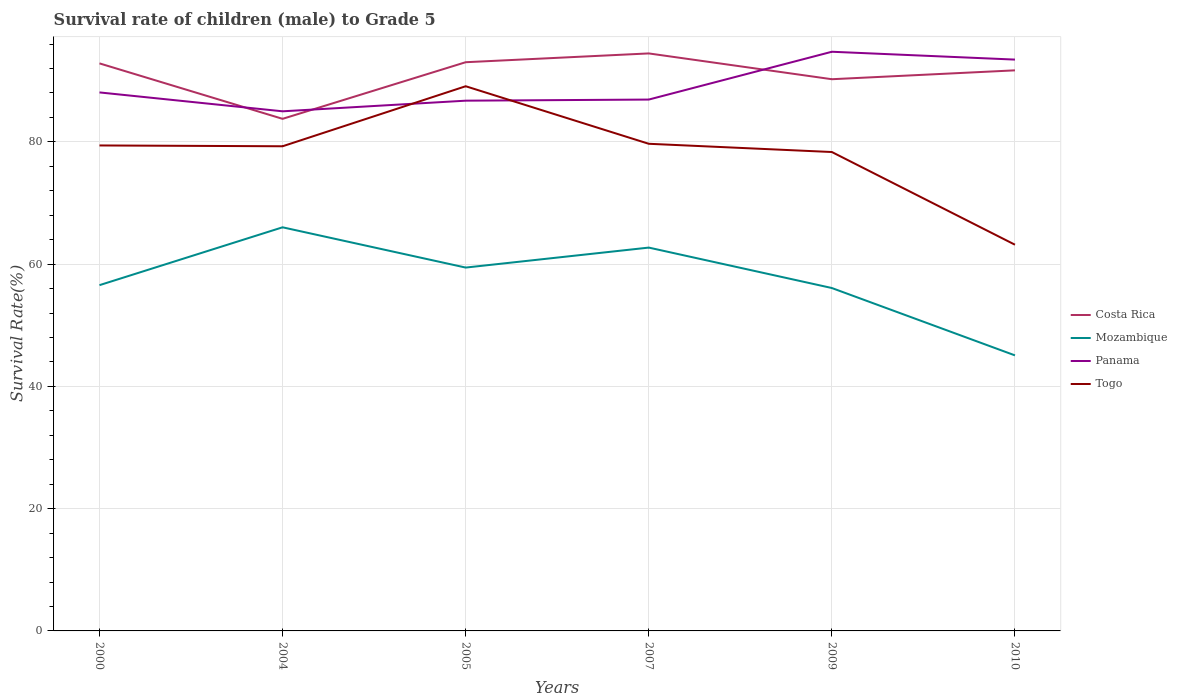Is the number of lines equal to the number of legend labels?
Make the answer very short. Yes. Across all years, what is the maximum survival rate of male children to grade 5 in Togo?
Your answer should be very brief. 63.17. In which year was the survival rate of male children to grade 5 in Costa Rica maximum?
Give a very brief answer. 2004. What is the total survival rate of male children to grade 5 in Costa Rica in the graph?
Provide a short and direct response. -10.7. What is the difference between the highest and the second highest survival rate of male children to grade 5 in Mozambique?
Your response must be concise. 20.95. What is the difference between the highest and the lowest survival rate of male children to grade 5 in Costa Rica?
Provide a succinct answer. 4. Is the survival rate of male children to grade 5 in Togo strictly greater than the survival rate of male children to grade 5 in Panama over the years?
Your answer should be compact. No. How many years are there in the graph?
Your response must be concise. 6. What is the difference between two consecutive major ticks on the Y-axis?
Provide a short and direct response. 20. Are the values on the major ticks of Y-axis written in scientific E-notation?
Provide a short and direct response. No. Does the graph contain any zero values?
Offer a terse response. No. Where does the legend appear in the graph?
Give a very brief answer. Center right. How are the legend labels stacked?
Your answer should be compact. Vertical. What is the title of the graph?
Ensure brevity in your answer.  Survival rate of children (male) to Grade 5. Does "Costa Rica" appear as one of the legend labels in the graph?
Your response must be concise. Yes. What is the label or title of the Y-axis?
Keep it short and to the point. Survival Rate(%). What is the Survival Rate(%) in Costa Rica in 2000?
Make the answer very short. 92.83. What is the Survival Rate(%) of Mozambique in 2000?
Offer a very short reply. 56.56. What is the Survival Rate(%) in Panama in 2000?
Your response must be concise. 88.08. What is the Survival Rate(%) of Togo in 2000?
Provide a short and direct response. 79.41. What is the Survival Rate(%) of Costa Rica in 2004?
Provide a succinct answer. 83.76. What is the Survival Rate(%) in Mozambique in 2004?
Give a very brief answer. 66.02. What is the Survival Rate(%) of Panama in 2004?
Keep it short and to the point. 84.99. What is the Survival Rate(%) in Togo in 2004?
Give a very brief answer. 79.28. What is the Survival Rate(%) in Costa Rica in 2005?
Offer a terse response. 93.02. What is the Survival Rate(%) in Mozambique in 2005?
Offer a terse response. 59.43. What is the Survival Rate(%) of Panama in 2005?
Your answer should be compact. 86.73. What is the Survival Rate(%) of Togo in 2005?
Your answer should be very brief. 89.09. What is the Survival Rate(%) of Costa Rica in 2007?
Provide a short and direct response. 94.46. What is the Survival Rate(%) of Mozambique in 2007?
Give a very brief answer. 62.7. What is the Survival Rate(%) of Panama in 2007?
Keep it short and to the point. 86.91. What is the Survival Rate(%) in Togo in 2007?
Offer a very short reply. 79.68. What is the Survival Rate(%) of Costa Rica in 2009?
Make the answer very short. 90.24. What is the Survival Rate(%) of Mozambique in 2009?
Your answer should be very brief. 56.09. What is the Survival Rate(%) in Panama in 2009?
Give a very brief answer. 94.73. What is the Survival Rate(%) in Togo in 2009?
Your answer should be very brief. 78.33. What is the Survival Rate(%) in Costa Rica in 2010?
Your answer should be compact. 91.69. What is the Survival Rate(%) of Mozambique in 2010?
Provide a succinct answer. 45.07. What is the Survival Rate(%) in Panama in 2010?
Provide a short and direct response. 93.45. What is the Survival Rate(%) in Togo in 2010?
Keep it short and to the point. 63.17. Across all years, what is the maximum Survival Rate(%) of Costa Rica?
Offer a terse response. 94.46. Across all years, what is the maximum Survival Rate(%) of Mozambique?
Your response must be concise. 66.02. Across all years, what is the maximum Survival Rate(%) of Panama?
Offer a terse response. 94.73. Across all years, what is the maximum Survival Rate(%) of Togo?
Ensure brevity in your answer.  89.09. Across all years, what is the minimum Survival Rate(%) of Costa Rica?
Offer a very short reply. 83.76. Across all years, what is the minimum Survival Rate(%) of Mozambique?
Keep it short and to the point. 45.07. Across all years, what is the minimum Survival Rate(%) of Panama?
Offer a terse response. 84.99. Across all years, what is the minimum Survival Rate(%) of Togo?
Your answer should be compact. 63.17. What is the total Survival Rate(%) in Costa Rica in the graph?
Give a very brief answer. 546.01. What is the total Survival Rate(%) in Mozambique in the graph?
Give a very brief answer. 345.87. What is the total Survival Rate(%) in Panama in the graph?
Offer a terse response. 534.91. What is the total Survival Rate(%) in Togo in the graph?
Provide a short and direct response. 468.96. What is the difference between the Survival Rate(%) of Costa Rica in 2000 and that in 2004?
Your answer should be compact. 9.07. What is the difference between the Survival Rate(%) of Mozambique in 2000 and that in 2004?
Offer a very short reply. -9.46. What is the difference between the Survival Rate(%) of Panama in 2000 and that in 2004?
Give a very brief answer. 3.09. What is the difference between the Survival Rate(%) in Togo in 2000 and that in 2004?
Keep it short and to the point. 0.13. What is the difference between the Survival Rate(%) of Costa Rica in 2000 and that in 2005?
Offer a terse response. -0.19. What is the difference between the Survival Rate(%) in Mozambique in 2000 and that in 2005?
Your response must be concise. -2.88. What is the difference between the Survival Rate(%) of Panama in 2000 and that in 2005?
Offer a very short reply. 1.35. What is the difference between the Survival Rate(%) of Togo in 2000 and that in 2005?
Your answer should be compact. -9.69. What is the difference between the Survival Rate(%) in Costa Rica in 2000 and that in 2007?
Your answer should be compact. -1.63. What is the difference between the Survival Rate(%) in Mozambique in 2000 and that in 2007?
Give a very brief answer. -6.14. What is the difference between the Survival Rate(%) in Panama in 2000 and that in 2007?
Make the answer very short. 1.17. What is the difference between the Survival Rate(%) of Togo in 2000 and that in 2007?
Your response must be concise. -0.27. What is the difference between the Survival Rate(%) in Costa Rica in 2000 and that in 2009?
Keep it short and to the point. 2.59. What is the difference between the Survival Rate(%) in Mozambique in 2000 and that in 2009?
Keep it short and to the point. 0.47. What is the difference between the Survival Rate(%) of Panama in 2000 and that in 2009?
Offer a very short reply. -6.65. What is the difference between the Survival Rate(%) in Togo in 2000 and that in 2009?
Your response must be concise. 1.07. What is the difference between the Survival Rate(%) in Costa Rica in 2000 and that in 2010?
Give a very brief answer. 1.14. What is the difference between the Survival Rate(%) of Mozambique in 2000 and that in 2010?
Provide a short and direct response. 11.49. What is the difference between the Survival Rate(%) of Panama in 2000 and that in 2010?
Your answer should be very brief. -5.37. What is the difference between the Survival Rate(%) of Togo in 2000 and that in 2010?
Offer a terse response. 16.24. What is the difference between the Survival Rate(%) in Costa Rica in 2004 and that in 2005?
Provide a short and direct response. -9.26. What is the difference between the Survival Rate(%) of Mozambique in 2004 and that in 2005?
Make the answer very short. 6.59. What is the difference between the Survival Rate(%) in Panama in 2004 and that in 2005?
Your answer should be compact. -1.74. What is the difference between the Survival Rate(%) in Togo in 2004 and that in 2005?
Offer a terse response. -9.82. What is the difference between the Survival Rate(%) in Costa Rica in 2004 and that in 2007?
Make the answer very short. -10.7. What is the difference between the Survival Rate(%) in Mozambique in 2004 and that in 2007?
Make the answer very short. 3.32. What is the difference between the Survival Rate(%) in Panama in 2004 and that in 2007?
Provide a succinct answer. -1.92. What is the difference between the Survival Rate(%) in Togo in 2004 and that in 2007?
Provide a succinct answer. -0.41. What is the difference between the Survival Rate(%) in Costa Rica in 2004 and that in 2009?
Your answer should be compact. -6.48. What is the difference between the Survival Rate(%) in Mozambique in 2004 and that in 2009?
Your response must be concise. 9.93. What is the difference between the Survival Rate(%) of Panama in 2004 and that in 2009?
Keep it short and to the point. -9.74. What is the difference between the Survival Rate(%) of Togo in 2004 and that in 2009?
Your answer should be compact. 0.94. What is the difference between the Survival Rate(%) in Costa Rica in 2004 and that in 2010?
Your answer should be very brief. -7.93. What is the difference between the Survival Rate(%) in Mozambique in 2004 and that in 2010?
Give a very brief answer. 20.95. What is the difference between the Survival Rate(%) of Panama in 2004 and that in 2010?
Keep it short and to the point. -8.46. What is the difference between the Survival Rate(%) in Togo in 2004 and that in 2010?
Keep it short and to the point. 16.1. What is the difference between the Survival Rate(%) in Costa Rica in 2005 and that in 2007?
Ensure brevity in your answer.  -1.44. What is the difference between the Survival Rate(%) in Mozambique in 2005 and that in 2007?
Your response must be concise. -3.27. What is the difference between the Survival Rate(%) of Panama in 2005 and that in 2007?
Provide a short and direct response. -0.18. What is the difference between the Survival Rate(%) of Togo in 2005 and that in 2007?
Keep it short and to the point. 9.41. What is the difference between the Survival Rate(%) of Costa Rica in 2005 and that in 2009?
Ensure brevity in your answer.  2.78. What is the difference between the Survival Rate(%) of Mozambique in 2005 and that in 2009?
Offer a terse response. 3.35. What is the difference between the Survival Rate(%) in Panama in 2005 and that in 2009?
Your answer should be very brief. -8. What is the difference between the Survival Rate(%) of Togo in 2005 and that in 2009?
Provide a short and direct response. 10.76. What is the difference between the Survival Rate(%) of Costa Rica in 2005 and that in 2010?
Keep it short and to the point. 1.33. What is the difference between the Survival Rate(%) of Mozambique in 2005 and that in 2010?
Give a very brief answer. 14.36. What is the difference between the Survival Rate(%) in Panama in 2005 and that in 2010?
Keep it short and to the point. -6.72. What is the difference between the Survival Rate(%) in Togo in 2005 and that in 2010?
Your answer should be compact. 25.92. What is the difference between the Survival Rate(%) in Costa Rica in 2007 and that in 2009?
Make the answer very short. 4.22. What is the difference between the Survival Rate(%) in Mozambique in 2007 and that in 2009?
Offer a very short reply. 6.61. What is the difference between the Survival Rate(%) of Panama in 2007 and that in 2009?
Ensure brevity in your answer.  -7.82. What is the difference between the Survival Rate(%) of Togo in 2007 and that in 2009?
Make the answer very short. 1.35. What is the difference between the Survival Rate(%) of Costa Rica in 2007 and that in 2010?
Keep it short and to the point. 2.77. What is the difference between the Survival Rate(%) in Mozambique in 2007 and that in 2010?
Ensure brevity in your answer.  17.63. What is the difference between the Survival Rate(%) of Panama in 2007 and that in 2010?
Keep it short and to the point. -6.54. What is the difference between the Survival Rate(%) in Togo in 2007 and that in 2010?
Make the answer very short. 16.51. What is the difference between the Survival Rate(%) in Costa Rica in 2009 and that in 2010?
Your answer should be compact. -1.45. What is the difference between the Survival Rate(%) in Mozambique in 2009 and that in 2010?
Ensure brevity in your answer.  11.02. What is the difference between the Survival Rate(%) of Panama in 2009 and that in 2010?
Your response must be concise. 1.28. What is the difference between the Survival Rate(%) of Togo in 2009 and that in 2010?
Your response must be concise. 15.16. What is the difference between the Survival Rate(%) in Costa Rica in 2000 and the Survival Rate(%) in Mozambique in 2004?
Your answer should be very brief. 26.81. What is the difference between the Survival Rate(%) of Costa Rica in 2000 and the Survival Rate(%) of Panama in 2004?
Keep it short and to the point. 7.84. What is the difference between the Survival Rate(%) in Costa Rica in 2000 and the Survival Rate(%) in Togo in 2004?
Provide a short and direct response. 13.56. What is the difference between the Survival Rate(%) of Mozambique in 2000 and the Survival Rate(%) of Panama in 2004?
Offer a very short reply. -28.44. What is the difference between the Survival Rate(%) in Mozambique in 2000 and the Survival Rate(%) in Togo in 2004?
Offer a terse response. -22.72. What is the difference between the Survival Rate(%) in Panama in 2000 and the Survival Rate(%) in Togo in 2004?
Make the answer very short. 8.81. What is the difference between the Survival Rate(%) in Costa Rica in 2000 and the Survival Rate(%) in Mozambique in 2005?
Offer a terse response. 33.4. What is the difference between the Survival Rate(%) of Costa Rica in 2000 and the Survival Rate(%) of Panama in 2005?
Offer a very short reply. 6.1. What is the difference between the Survival Rate(%) of Costa Rica in 2000 and the Survival Rate(%) of Togo in 2005?
Give a very brief answer. 3.74. What is the difference between the Survival Rate(%) of Mozambique in 2000 and the Survival Rate(%) of Panama in 2005?
Offer a very short reply. -30.17. What is the difference between the Survival Rate(%) in Mozambique in 2000 and the Survival Rate(%) in Togo in 2005?
Ensure brevity in your answer.  -32.54. What is the difference between the Survival Rate(%) in Panama in 2000 and the Survival Rate(%) in Togo in 2005?
Your answer should be very brief. -1.01. What is the difference between the Survival Rate(%) of Costa Rica in 2000 and the Survival Rate(%) of Mozambique in 2007?
Your answer should be very brief. 30.13. What is the difference between the Survival Rate(%) in Costa Rica in 2000 and the Survival Rate(%) in Panama in 2007?
Ensure brevity in your answer.  5.92. What is the difference between the Survival Rate(%) of Costa Rica in 2000 and the Survival Rate(%) of Togo in 2007?
Give a very brief answer. 13.15. What is the difference between the Survival Rate(%) of Mozambique in 2000 and the Survival Rate(%) of Panama in 2007?
Your response must be concise. -30.36. What is the difference between the Survival Rate(%) of Mozambique in 2000 and the Survival Rate(%) of Togo in 2007?
Offer a terse response. -23.12. What is the difference between the Survival Rate(%) in Panama in 2000 and the Survival Rate(%) in Togo in 2007?
Offer a very short reply. 8.4. What is the difference between the Survival Rate(%) of Costa Rica in 2000 and the Survival Rate(%) of Mozambique in 2009?
Offer a very short reply. 36.75. What is the difference between the Survival Rate(%) of Costa Rica in 2000 and the Survival Rate(%) of Panama in 2009?
Provide a succinct answer. -1.9. What is the difference between the Survival Rate(%) of Costa Rica in 2000 and the Survival Rate(%) of Togo in 2009?
Keep it short and to the point. 14.5. What is the difference between the Survival Rate(%) of Mozambique in 2000 and the Survival Rate(%) of Panama in 2009?
Offer a very short reply. -38.18. What is the difference between the Survival Rate(%) in Mozambique in 2000 and the Survival Rate(%) in Togo in 2009?
Provide a short and direct response. -21.78. What is the difference between the Survival Rate(%) of Panama in 2000 and the Survival Rate(%) of Togo in 2009?
Offer a very short reply. 9.75. What is the difference between the Survival Rate(%) of Costa Rica in 2000 and the Survival Rate(%) of Mozambique in 2010?
Ensure brevity in your answer.  47.76. What is the difference between the Survival Rate(%) in Costa Rica in 2000 and the Survival Rate(%) in Panama in 2010?
Give a very brief answer. -0.62. What is the difference between the Survival Rate(%) in Costa Rica in 2000 and the Survival Rate(%) in Togo in 2010?
Give a very brief answer. 29.66. What is the difference between the Survival Rate(%) of Mozambique in 2000 and the Survival Rate(%) of Panama in 2010?
Your response must be concise. -36.9. What is the difference between the Survival Rate(%) of Mozambique in 2000 and the Survival Rate(%) of Togo in 2010?
Your response must be concise. -6.62. What is the difference between the Survival Rate(%) of Panama in 2000 and the Survival Rate(%) of Togo in 2010?
Your answer should be very brief. 24.91. What is the difference between the Survival Rate(%) of Costa Rica in 2004 and the Survival Rate(%) of Mozambique in 2005?
Give a very brief answer. 24.33. What is the difference between the Survival Rate(%) of Costa Rica in 2004 and the Survival Rate(%) of Panama in 2005?
Keep it short and to the point. -2.97. What is the difference between the Survival Rate(%) in Costa Rica in 2004 and the Survival Rate(%) in Togo in 2005?
Your answer should be very brief. -5.33. What is the difference between the Survival Rate(%) of Mozambique in 2004 and the Survival Rate(%) of Panama in 2005?
Give a very brief answer. -20.71. What is the difference between the Survival Rate(%) of Mozambique in 2004 and the Survival Rate(%) of Togo in 2005?
Ensure brevity in your answer.  -23.07. What is the difference between the Survival Rate(%) in Panama in 2004 and the Survival Rate(%) in Togo in 2005?
Make the answer very short. -4.1. What is the difference between the Survival Rate(%) of Costa Rica in 2004 and the Survival Rate(%) of Mozambique in 2007?
Make the answer very short. 21.06. What is the difference between the Survival Rate(%) in Costa Rica in 2004 and the Survival Rate(%) in Panama in 2007?
Offer a very short reply. -3.15. What is the difference between the Survival Rate(%) of Costa Rica in 2004 and the Survival Rate(%) of Togo in 2007?
Ensure brevity in your answer.  4.08. What is the difference between the Survival Rate(%) in Mozambique in 2004 and the Survival Rate(%) in Panama in 2007?
Make the answer very short. -20.89. What is the difference between the Survival Rate(%) in Mozambique in 2004 and the Survival Rate(%) in Togo in 2007?
Make the answer very short. -13.66. What is the difference between the Survival Rate(%) in Panama in 2004 and the Survival Rate(%) in Togo in 2007?
Your response must be concise. 5.31. What is the difference between the Survival Rate(%) of Costa Rica in 2004 and the Survival Rate(%) of Mozambique in 2009?
Ensure brevity in your answer.  27.67. What is the difference between the Survival Rate(%) in Costa Rica in 2004 and the Survival Rate(%) in Panama in 2009?
Offer a terse response. -10.97. What is the difference between the Survival Rate(%) in Costa Rica in 2004 and the Survival Rate(%) in Togo in 2009?
Offer a very short reply. 5.43. What is the difference between the Survival Rate(%) in Mozambique in 2004 and the Survival Rate(%) in Panama in 2009?
Ensure brevity in your answer.  -28.71. What is the difference between the Survival Rate(%) of Mozambique in 2004 and the Survival Rate(%) of Togo in 2009?
Provide a short and direct response. -12.31. What is the difference between the Survival Rate(%) of Panama in 2004 and the Survival Rate(%) of Togo in 2009?
Offer a very short reply. 6.66. What is the difference between the Survival Rate(%) in Costa Rica in 2004 and the Survival Rate(%) in Mozambique in 2010?
Make the answer very short. 38.69. What is the difference between the Survival Rate(%) of Costa Rica in 2004 and the Survival Rate(%) of Panama in 2010?
Your answer should be compact. -9.69. What is the difference between the Survival Rate(%) of Costa Rica in 2004 and the Survival Rate(%) of Togo in 2010?
Provide a short and direct response. 20.59. What is the difference between the Survival Rate(%) of Mozambique in 2004 and the Survival Rate(%) of Panama in 2010?
Your answer should be very brief. -27.43. What is the difference between the Survival Rate(%) of Mozambique in 2004 and the Survival Rate(%) of Togo in 2010?
Make the answer very short. 2.85. What is the difference between the Survival Rate(%) in Panama in 2004 and the Survival Rate(%) in Togo in 2010?
Give a very brief answer. 21.82. What is the difference between the Survival Rate(%) in Costa Rica in 2005 and the Survival Rate(%) in Mozambique in 2007?
Give a very brief answer. 30.32. What is the difference between the Survival Rate(%) of Costa Rica in 2005 and the Survival Rate(%) of Panama in 2007?
Your answer should be very brief. 6.11. What is the difference between the Survival Rate(%) of Costa Rica in 2005 and the Survival Rate(%) of Togo in 2007?
Make the answer very short. 13.34. What is the difference between the Survival Rate(%) of Mozambique in 2005 and the Survival Rate(%) of Panama in 2007?
Provide a short and direct response. -27.48. What is the difference between the Survival Rate(%) of Mozambique in 2005 and the Survival Rate(%) of Togo in 2007?
Your answer should be compact. -20.25. What is the difference between the Survival Rate(%) in Panama in 2005 and the Survival Rate(%) in Togo in 2007?
Ensure brevity in your answer.  7.05. What is the difference between the Survival Rate(%) in Costa Rica in 2005 and the Survival Rate(%) in Mozambique in 2009?
Ensure brevity in your answer.  36.93. What is the difference between the Survival Rate(%) of Costa Rica in 2005 and the Survival Rate(%) of Panama in 2009?
Provide a succinct answer. -1.71. What is the difference between the Survival Rate(%) in Costa Rica in 2005 and the Survival Rate(%) in Togo in 2009?
Make the answer very short. 14.69. What is the difference between the Survival Rate(%) in Mozambique in 2005 and the Survival Rate(%) in Panama in 2009?
Offer a very short reply. -35.3. What is the difference between the Survival Rate(%) of Mozambique in 2005 and the Survival Rate(%) of Togo in 2009?
Your answer should be compact. -18.9. What is the difference between the Survival Rate(%) in Panama in 2005 and the Survival Rate(%) in Togo in 2009?
Provide a succinct answer. 8.4. What is the difference between the Survival Rate(%) of Costa Rica in 2005 and the Survival Rate(%) of Mozambique in 2010?
Ensure brevity in your answer.  47.95. What is the difference between the Survival Rate(%) in Costa Rica in 2005 and the Survival Rate(%) in Panama in 2010?
Offer a very short reply. -0.43. What is the difference between the Survival Rate(%) of Costa Rica in 2005 and the Survival Rate(%) of Togo in 2010?
Give a very brief answer. 29.85. What is the difference between the Survival Rate(%) of Mozambique in 2005 and the Survival Rate(%) of Panama in 2010?
Keep it short and to the point. -34.02. What is the difference between the Survival Rate(%) of Mozambique in 2005 and the Survival Rate(%) of Togo in 2010?
Keep it short and to the point. -3.74. What is the difference between the Survival Rate(%) in Panama in 2005 and the Survival Rate(%) in Togo in 2010?
Provide a succinct answer. 23.56. What is the difference between the Survival Rate(%) in Costa Rica in 2007 and the Survival Rate(%) in Mozambique in 2009?
Provide a short and direct response. 38.37. What is the difference between the Survival Rate(%) of Costa Rica in 2007 and the Survival Rate(%) of Panama in 2009?
Keep it short and to the point. -0.27. What is the difference between the Survival Rate(%) in Costa Rica in 2007 and the Survival Rate(%) in Togo in 2009?
Your answer should be very brief. 16.13. What is the difference between the Survival Rate(%) in Mozambique in 2007 and the Survival Rate(%) in Panama in 2009?
Your answer should be compact. -32.03. What is the difference between the Survival Rate(%) in Mozambique in 2007 and the Survival Rate(%) in Togo in 2009?
Ensure brevity in your answer.  -15.63. What is the difference between the Survival Rate(%) of Panama in 2007 and the Survival Rate(%) of Togo in 2009?
Your answer should be compact. 8.58. What is the difference between the Survival Rate(%) in Costa Rica in 2007 and the Survival Rate(%) in Mozambique in 2010?
Provide a short and direct response. 49.39. What is the difference between the Survival Rate(%) in Costa Rica in 2007 and the Survival Rate(%) in Togo in 2010?
Your answer should be compact. 31.29. What is the difference between the Survival Rate(%) of Mozambique in 2007 and the Survival Rate(%) of Panama in 2010?
Give a very brief answer. -30.75. What is the difference between the Survival Rate(%) in Mozambique in 2007 and the Survival Rate(%) in Togo in 2010?
Your response must be concise. -0.47. What is the difference between the Survival Rate(%) of Panama in 2007 and the Survival Rate(%) of Togo in 2010?
Keep it short and to the point. 23.74. What is the difference between the Survival Rate(%) of Costa Rica in 2009 and the Survival Rate(%) of Mozambique in 2010?
Your response must be concise. 45.17. What is the difference between the Survival Rate(%) of Costa Rica in 2009 and the Survival Rate(%) of Panama in 2010?
Your answer should be compact. -3.21. What is the difference between the Survival Rate(%) of Costa Rica in 2009 and the Survival Rate(%) of Togo in 2010?
Your answer should be compact. 27.07. What is the difference between the Survival Rate(%) in Mozambique in 2009 and the Survival Rate(%) in Panama in 2010?
Ensure brevity in your answer.  -37.37. What is the difference between the Survival Rate(%) in Mozambique in 2009 and the Survival Rate(%) in Togo in 2010?
Offer a terse response. -7.09. What is the difference between the Survival Rate(%) in Panama in 2009 and the Survival Rate(%) in Togo in 2010?
Give a very brief answer. 31.56. What is the average Survival Rate(%) of Costa Rica per year?
Give a very brief answer. 91. What is the average Survival Rate(%) in Mozambique per year?
Keep it short and to the point. 57.64. What is the average Survival Rate(%) in Panama per year?
Keep it short and to the point. 89.15. What is the average Survival Rate(%) in Togo per year?
Your answer should be very brief. 78.16. In the year 2000, what is the difference between the Survival Rate(%) of Costa Rica and Survival Rate(%) of Mozambique?
Offer a terse response. 36.27. In the year 2000, what is the difference between the Survival Rate(%) in Costa Rica and Survival Rate(%) in Panama?
Give a very brief answer. 4.75. In the year 2000, what is the difference between the Survival Rate(%) of Costa Rica and Survival Rate(%) of Togo?
Your response must be concise. 13.42. In the year 2000, what is the difference between the Survival Rate(%) in Mozambique and Survival Rate(%) in Panama?
Make the answer very short. -31.53. In the year 2000, what is the difference between the Survival Rate(%) of Mozambique and Survival Rate(%) of Togo?
Provide a short and direct response. -22.85. In the year 2000, what is the difference between the Survival Rate(%) of Panama and Survival Rate(%) of Togo?
Offer a very short reply. 8.67. In the year 2004, what is the difference between the Survival Rate(%) of Costa Rica and Survival Rate(%) of Mozambique?
Keep it short and to the point. 17.74. In the year 2004, what is the difference between the Survival Rate(%) of Costa Rica and Survival Rate(%) of Panama?
Provide a short and direct response. -1.23. In the year 2004, what is the difference between the Survival Rate(%) of Costa Rica and Survival Rate(%) of Togo?
Provide a succinct answer. 4.49. In the year 2004, what is the difference between the Survival Rate(%) of Mozambique and Survival Rate(%) of Panama?
Give a very brief answer. -18.97. In the year 2004, what is the difference between the Survival Rate(%) in Mozambique and Survival Rate(%) in Togo?
Ensure brevity in your answer.  -13.26. In the year 2004, what is the difference between the Survival Rate(%) in Panama and Survival Rate(%) in Togo?
Provide a succinct answer. 5.72. In the year 2005, what is the difference between the Survival Rate(%) in Costa Rica and Survival Rate(%) in Mozambique?
Your response must be concise. 33.59. In the year 2005, what is the difference between the Survival Rate(%) of Costa Rica and Survival Rate(%) of Panama?
Offer a very short reply. 6.29. In the year 2005, what is the difference between the Survival Rate(%) in Costa Rica and Survival Rate(%) in Togo?
Keep it short and to the point. 3.93. In the year 2005, what is the difference between the Survival Rate(%) in Mozambique and Survival Rate(%) in Panama?
Provide a succinct answer. -27.3. In the year 2005, what is the difference between the Survival Rate(%) in Mozambique and Survival Rate(%) in Togo?
Offer a very short reply. -29.66. In the year 2005, what is the difference between the Survival Rate(%) in Panama and Survival Rate(%) in Togo?
Keep it short and to the point. -2.36. In the year 2007, what is the difference between the Survival Rate(%) of Costa Rica and Survival Rate(%) of Mozambique?
Give a very brief answer. 31.76. In the year 2007, what is the difference between the Survival Rate(%) in Costa Rica and Survival Rate(%) in Panama?
Make the answer very short. 7.55. In the year 2007, what is the difference between the Survival Rate(%) in Costa Rica and Survival Rate(%) in Togo?
Give a very brief answer. 14.78. In the year 2007, what is the difference between the Survival Rate(%) in Mozambique and Survival Rate(%) in Panama?
Make the answer very short. -24.21. In the year 2007, what is the difference between the Survival Rate(%) in Mozambique and Survival Rate(%) in Togo?
Give a very brief answer. -16.98. In the year 2007, what is the difference between the Survival Rate(%) in Panama and Survival Rate(%) in Togo?
Offer a terse response. 7.23. In the year 2009, what is the difference between the Survival Rate(%) in Costa Rica and Survival Rate(%) in Mozambique?
Provide a short and direct response. 34.15. In the year 2009, what is the difference between the Survival Rate(%) in Costa Rica and Survival Rate(%) in Panama?
Ensure brevity in your answer.  -4.49. In the year 2009, what is the difference between the Survival Rate(%) in Costa Rica and Survival Rate(%) in Togo?
Provide a short and direct response. 11.91. In the year 2009, what is the difference between the Survival Rate(%) of Mozambique and Survival Rate(%) of Panama?
Give a very brief answer. -38.65. In the year 2009, what is the difference between the Survival Rate(%) of Mozambique and Survival Rate(%) of Togo?
Make the answer very short. -22.25. In the year 2009, what is the difference between the Survival Rate(%) of Panama and Survival Rate(%) of Togo?
Your answer should be very brief. 16.4. In the year 2010, what is the difference between the Survival Rate(%) in Costa Rica and Survival Rate(%) in Mozambique?
Ensure brevity in your answer.  46.62. In the year 2010, what is the difference between the Survival Rate(%) in Costa Rica and Survival Rate(%) in Panama?
Give a very brief answer. -1.76. In the year 2010, what is the difference between the Survival Rate(%) in Costa Rica and Survival Rate(%) in Togo?
Your answer should be very brief. 28.52. In the year 2010, what is the difference between the Survival Rate(%) of Mozambique and Survival Rate(%) of Panama?
Offer a terse response. -48.38. In the year 2010, what is the difference between the Survival Rate(%) in Mozambique and Survival Rate(%) in Togo?
Your answer should be compact. -18.1. In the year 2010, what is the difference between the Survival Rate(%) in Panama and Survival Rate(%) in Togo?
Your answer should be compact. 30.28. What is the ratio of the Survival Rate(%) in Costa Rica in 2000 to that in 2004?
Make the answer very short. 1.11. What is the ratio of the Survival Rate(%) of Mozambique in 2000 to that in 2004?
Offer a very short reply. 0.86. What is the ratio of the Survival Rate(%) of Panama in 2000 to that in 2004?
Ensure brevity in your answer.  1.04. What is the ratio of the Survival Rate(%) in Mozambique in 2000 to that in 2005?
Provide a succinct answer. 0.95. What is the ratio of the Survival Rate(%) in Panama in 2000 to that in 2005?
Provide a succinct answer. 1.02. What is the ratio of the Survival Rate(%) of Togo in 2000 to that in 2005?
Provide a short and direct response. 0.89. What is the ratio of the Survival Rate(%) in Costa Rica in 2000 to that in 2007?
Offer a terse response. 0.98. What is the ratio of the Survival Rate(%) in Mozambique in 2000 to that in 2007?
Keep it short and to the point. 0.9. What is the ratio of the Survival Rate(%) in Panama in 2000 to that in 2007?
Give a very brief answer. 1.01. What is the ratio of the Survival Rate(%) of Costa Rica in 2000 to that in 2009?
Give a very brief answer. 1.03. What is the ratio of the Survival Rate(%) of Mozambique in 2000 to that in 2009?
Provide a short and direct response. 1.01. What is the ratio of the Survival Rate(%) in Panama in 2000 to that in 2009?
Provide a succinct answer. 0.93. What is the ratio of the Survival Rate(%) in Togo in 2000 to that in 2009?
Ensure brevity in your answer.  1.01. What is the ratio of the Survival Rate(%) in Costa Rica in 2000 to that in 2010?
Offer a terse response. 1.01. What is the ratio of the Survival Rate(%) in Mozambique in 2000 to that in 2010?
Provide a short and direct response. 1.25. What is the ratio of the Survival Rate(%) in Panama in 2000 to that in 2010?
Give a very brief answer. 0.94. What is the ratio of the Survival Rate(%) of Togo in 2000 to that in 2010?
Provide a short and direct response. 1.26. What is the ratio of the Survival Rate(%) in Costa Rica in 2004 to that in 2005?
Your answer should be compact. 0.9. What is the ratio of the Survival Rate(%) of Mozambique in 2004 to that in 2005?
Your answer should be compact. 1.11. What is the ratio of the Survival Rate(%) in Togo in 2004 to that in 2005?
Your response must be concise. 0.89. What is the ratio of the Survival Rate(%) in Costa Rica in 2004 to that in 2007?
Provide a short and direct response. 0.89. What is the ratio of the Survival Rate(%) of Mozambique in 2004 to that in 2007?
Your answer should be very brief. 1.05. What is the ratio of the Survival Rate(%) in Panama in 2004 to that in 2007?
Provide a short and direct response. 0.98. What is the ratio of the Survival Rate(%) of Costa Rica in 2004 to that in 2009?
Make the answer very short. 0.93. What is the ratio of the Survival Rate(%) of Mozambique in 2004 to that in 2009?
Your response must be concise. 1.18. What is the ratio of the Survival Rate(%) in Panama in 2004 to that in 2009?
Your response must be concise. 0.9. What is the ratio of the Survival Rate(%) of Costa Rica in 2004 to that in 2010?
Keep it short and to the point. 0.91. What is the ratio of the Survival Rate(%) of Mozambique in 2004 to that in 2010?
Keep it short and to the point. 1.46. What is the ratio of the Survival Rate(%) of Panama in 2004 to that in 2010?
Your response must be concise. 0.91. What is the ratio of the Survival Rate(%) in Togo in 2004 to that in 2010?
Provide a succinct answer. 1.25. What is the ratio of the Survival Rate(%) in Costa Rica in 2005 to that in 2007?
Offer a terse response. 0.98. What is the ratio of the Survival Rate(%) in Mozambique in 2005 to that in 2007?
Ensure brevity in your answer.  0.95. What is the ratio of the Survival Rate(%) in Panama in 2005 to that in 2007?
Your answer should be very brief. 1. What is the ratio of the Survival Rate(%) in Togo in 2005 to that in 2007?
Give a very brief answer. 1.12. What is the ratio of the Survival Rate(%) in Costa Rica in 2005 to that in 2009?
Make the answer very short. 1.03. What is the ratio of the Survival Rate(%) of Mozambique in 2005 to that in 2009?
Offer a terse response. 1.06. What is the ratio of the Survival Rate(%) in Panama in 2005 to that in 2009?
Keep it short and to the point. 0.92. What is the ratio of the Survival Rate(%) of Togo in 2005 to that in 2009?
Your answer should be compact. 1.14. What is the ratio of the Survival Rate(%) of Costa Rica in 2005 to that in 2010?
Ensure brevity in your answer.  1.01. What is the ratio of the Survival Rate(%) in Mozambique in 2005 to that in 2010?
Give a very brief answer. 1.32. What is the ratio of the Survival Rate(%) in Panama in 2005 to that in 2010?
Make the answer very short. 0.93. What is the ratio of the Survival Rate(%) of Togo in 2005 to that in 2010?
Your answer should be compact. 1.41. What is the ratio of the Survival Rate(%) of Costa Rica in 2007 to that in 2009?
Your answer should be compact. 1.05. What is the ratio of the Survival Rate(%) of Mozambique in 2007 to that in 2009?
Give a very brief answer. 1.12. What is the ratio of the Survival Rate(%) of Panama in 2007 to that in 2009?
Offer a very short reply. 0.92. What is the ratio of the Survival Rate(%) in Togo in 2007 to that in 2009?
Make the answer very short. 1.02. What is the ratio of the Survival Rate(%) in Costa Rica in 2007 to that in 2010?
Make the answer very short. 1.03. What is the ratio of the Survival Rate(%) in Mozambique in 2007 to that in 2010?
Your answer should be compact. 1.39. What is the ratio of the Survival Rate(%) in Panama in 2007 to that in 2010?
Keep it short and to the point. 0.93. What is the ratio of the Survival Rate(%) in Togo in 2007 to that in 2010?
Your answer should be compact. 1.26. What is the ratio of the Survival Rate(%) of Costa Rica in 2009 to that in 2010?
Ensure brevity in your answer.  0.98. What is the ratio of the Survival Rate(%) in Mozambique in 2009 to that in 2010?
Keep it short and to the point. 1.24. What is the ratio of the Survival Rate(%) of Panama in 2009 to that in 2010?
Your response must be concise. 1.01. What is the ratio of the Survival Rate(%) in Togo in 2009 to that in 2010?
Your answer should be compact. 1.24. What is the difference between the highest and the second highest Survival Rate(%) of Costa Rica?
Keep it short and to the point. 1.44. What is the difference between the highest and the second highest Survival Rate(%) in Mozambique?
Your answer should be very brief. 3.32. What is the difference between the highest and the second highest Survival Rate(%) in Panama?
Keep it short and to the point. 1.28. What is the difference between the highest and the second highest Survival Rate(%) of Togo?
Provide a succinct answer. 9.41. What is the difference between the highest and the lowest Survival Rate(%) in Costa Rica?
Give a very brief answer. 10.7. What is the difference between the highest and the lowest Survival Rate(%) of Mozambique?
Your answer should be very brief. 20.95. What is the difference between the highest and the lowest Survival Rate(%) of Panama?
Provide a short and direct response. 9.74. What is the difference between the highest and the lowest Survival Rate(%) in Togo?
Your answer should be compact. 25.92. 